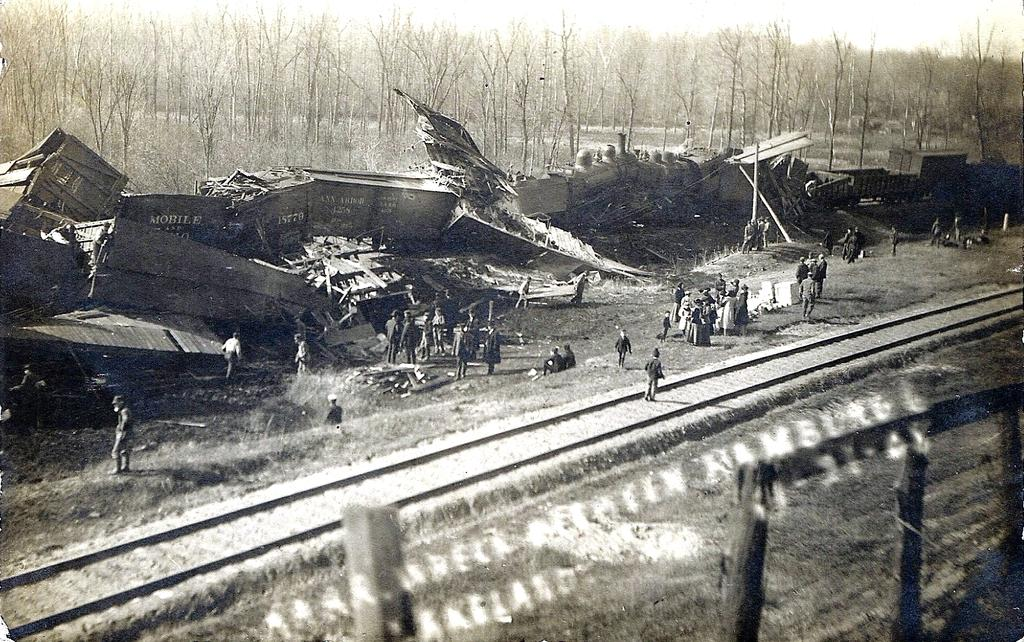What is the main feature of the image? There is a railway track in the image. What are the people in the image doing? People are standing behind the railway track. What type of objects can be seen in the image? There are metal objects in the image. What can be seen in the background of the image? Dry trees are visible in the background of the image. What type of form does the feeling of end take in the image? There is no reference to a form or feeling of end in the image; it primarily features a railway track and people standing nearby. 